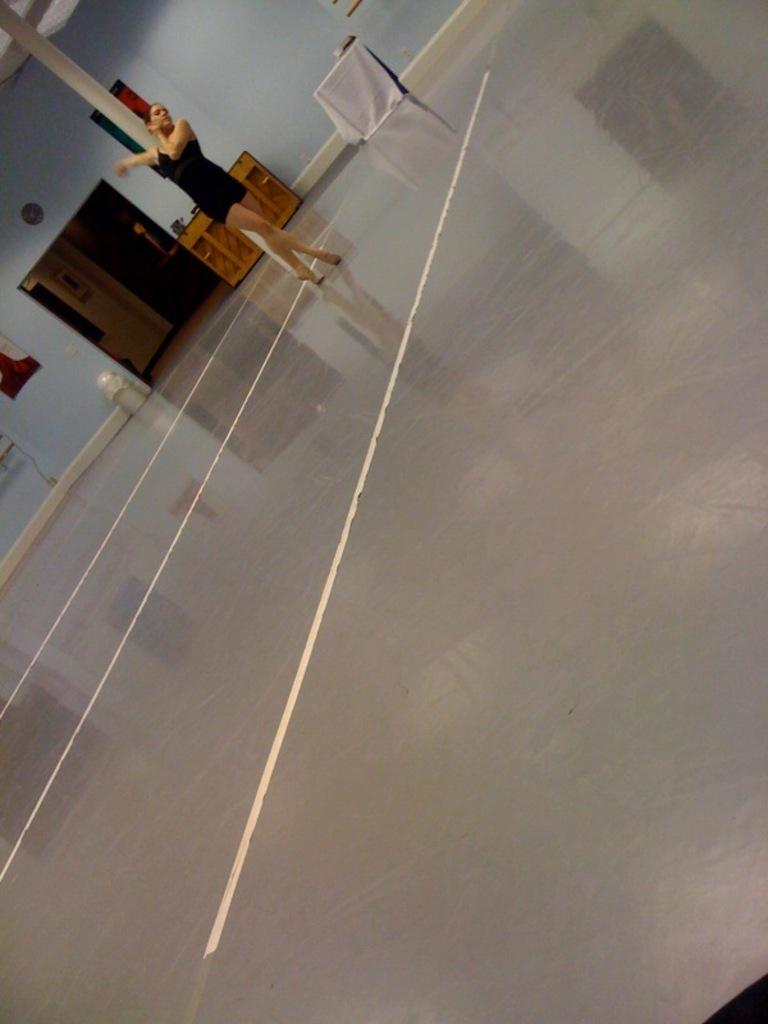What is the person in the image doing? The person is on the floor in the image. What can be seen on the table in the image? There are objects on a table in the image. What is hanging on the wall in the background of the image? There is a photo frame on the wall in the background of the image. How does the person in the image need to be quiet? There is no indication in the image that the person needs to be quiet, nor is there any context provided to suggest this. 